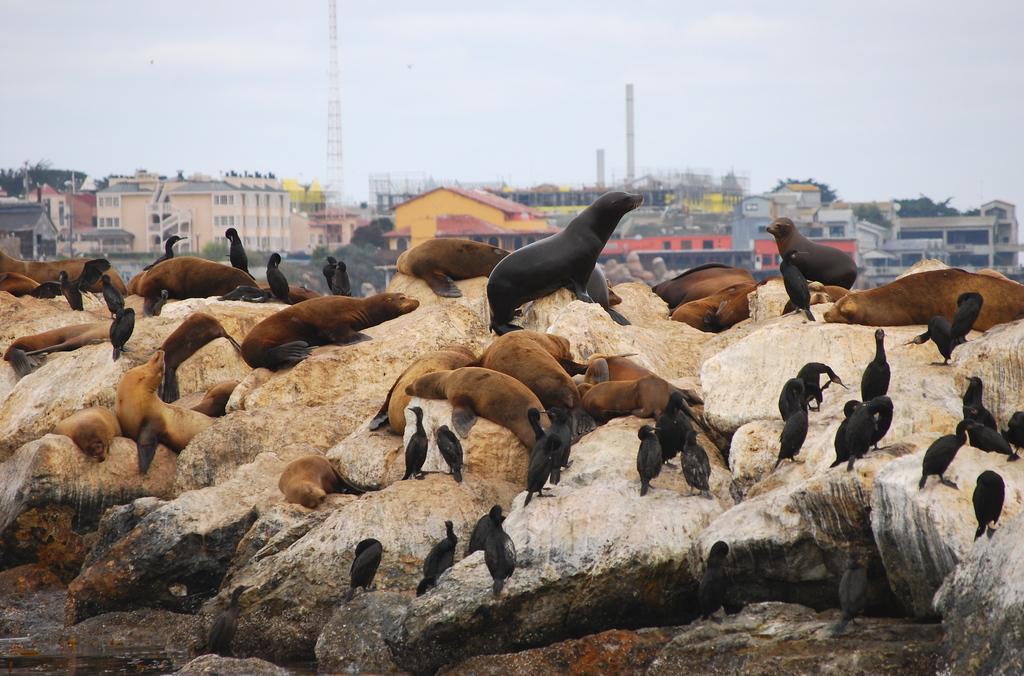Can you describe this image briefly? In this image I can see many animals and birds which are in black and brown color. These are on the rocks. In the background there are many buildings, towers and the sky. 